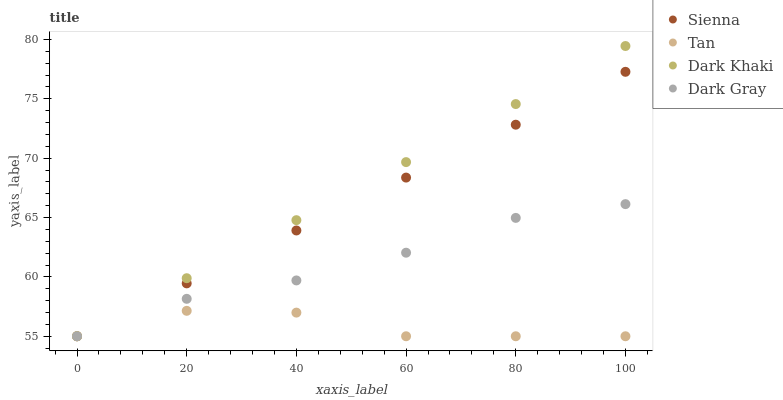Does Tan have the minimum area under the curve?
Answer yes or no. Yes. Does Dark Khaki have the maximum area under the curve?
Answer yes or no. Yes. Does Dark Khaki have the minimum area under the curve?
Answer yes or no. No. Does Tan have the maximum area under the curve?
Answer yes or no. No. Is Sienna the smoothest?
Answer yes or no. Yes. Is Tan the roughest?
Answer yes or no. Yes. Is Dark Khaki the smoothest?
Answer yes or no. No. Is Dark Khaki the roughest?
Answer yes or no. No. Does Sienna have the lowest value?
Answer yes or no. Yes. Does Dark Khaki have the highest value?
Answer yes or no. Yes. Does Tan have the highest value?
Answer yes or no. No. Does Dark Khaki intersect Sienna?
Answer yes or no. Yes. Is Dark Khaki less than Sienna?
Answer yes or no. No. Is Dark Khaki greater than Sienna?
Answer yes or no. No. 